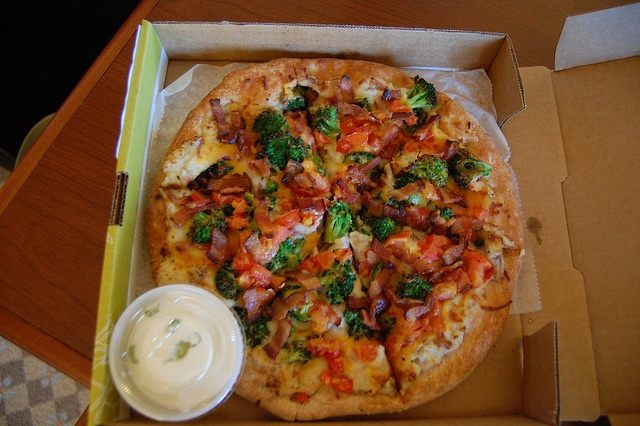Describe the objects in this image and their specific colors. I can see dining table in maroon, brown, olive, black, and darkgray tones, pizza in black, brown, and maroon tones, pizza in black, brown, and maroon tones, pizza in black, brown, and maroon tones, and pizza in black, brown, maroon, and olive tones in this image. 